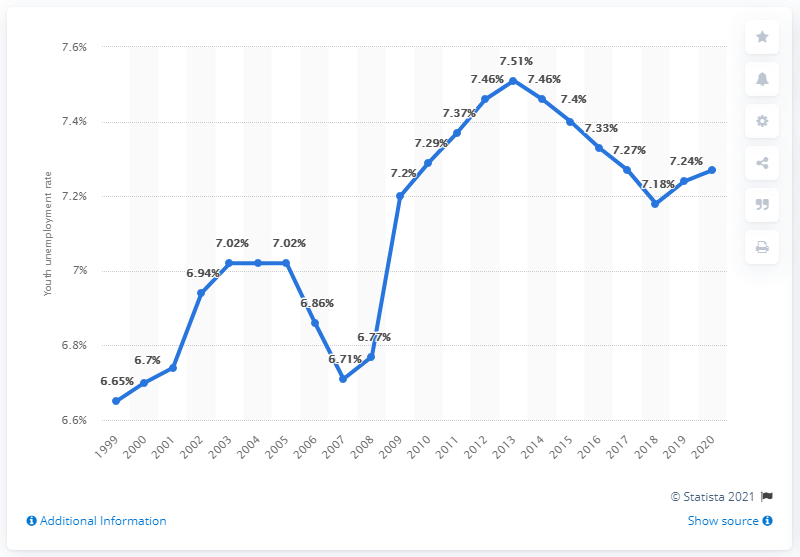Mention a couple of crucial points in this snapshot. In 2020, the youth unemployment rate in Kenya was 7.27%. 